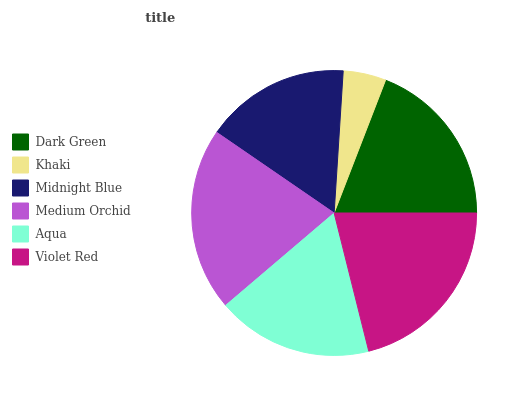Is Khaki the minimum?
Answer yes or no. Yes. Is Violet Red the maximum?
Answer yes or no. Yes. Is Midnight Blue the minimum?
Answer yes or no. No. Is Midnight Blue the maximum?
Answer yes or no. No. Is Midnight Blue greater than Khaki?
Answer yes or no. Yes. Is Khaki less than Midnight Blue?
Answer yes or no. Yes. Is Khaki greater than Midnight Blue?
Answer yes or no. No. Is Midnight Blue less than Khaki?
Answer yes or no. No. Is Dark Green the high median?
Answer yes or no. Yes. Is Aqua the low median?
Answer yes or no. Yes. Is Khaki the high median?
Answer yes or no. No. Is Medium Orchid the low median?
Answer yes or no. No. 